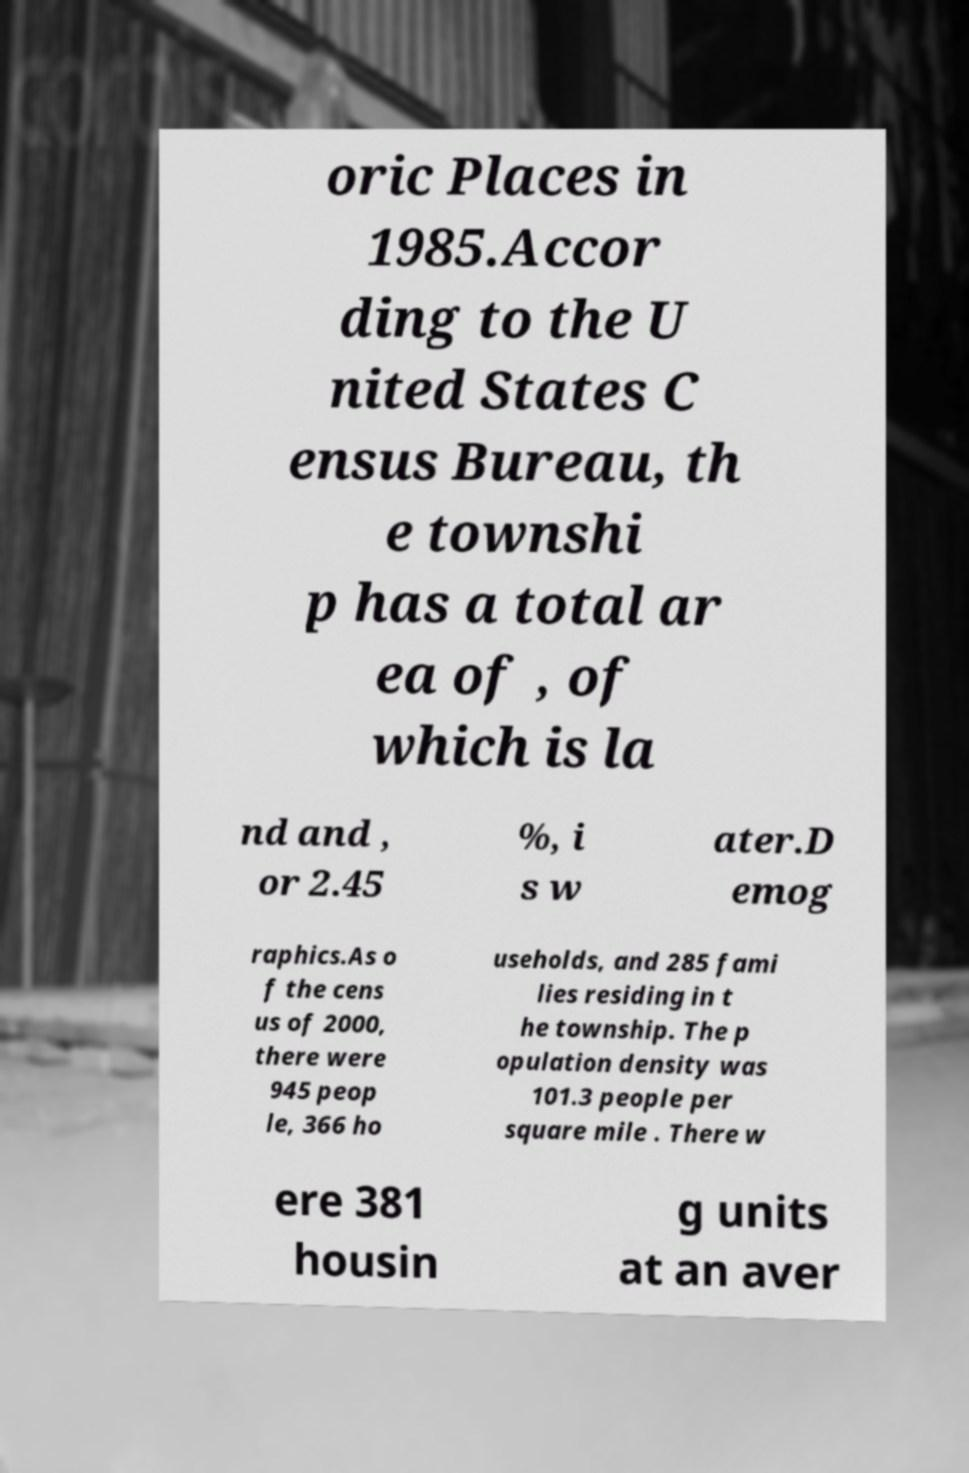Could you extract and type out the text from this image? oric Places in 1985.Accor ding to the U nited States C ensus Bureau, th e townshi p has a total ar ea of , of which is la nd and , or 2.45 %, i s w ater.D emog raphics.As o f the cens us of 2000, there were 945 peop le, 366 ho useholds, and 285 fami lies residing in t he township. The p opulation density was 101.3 people per square mile . There w ere 381 housin g units at an aver 